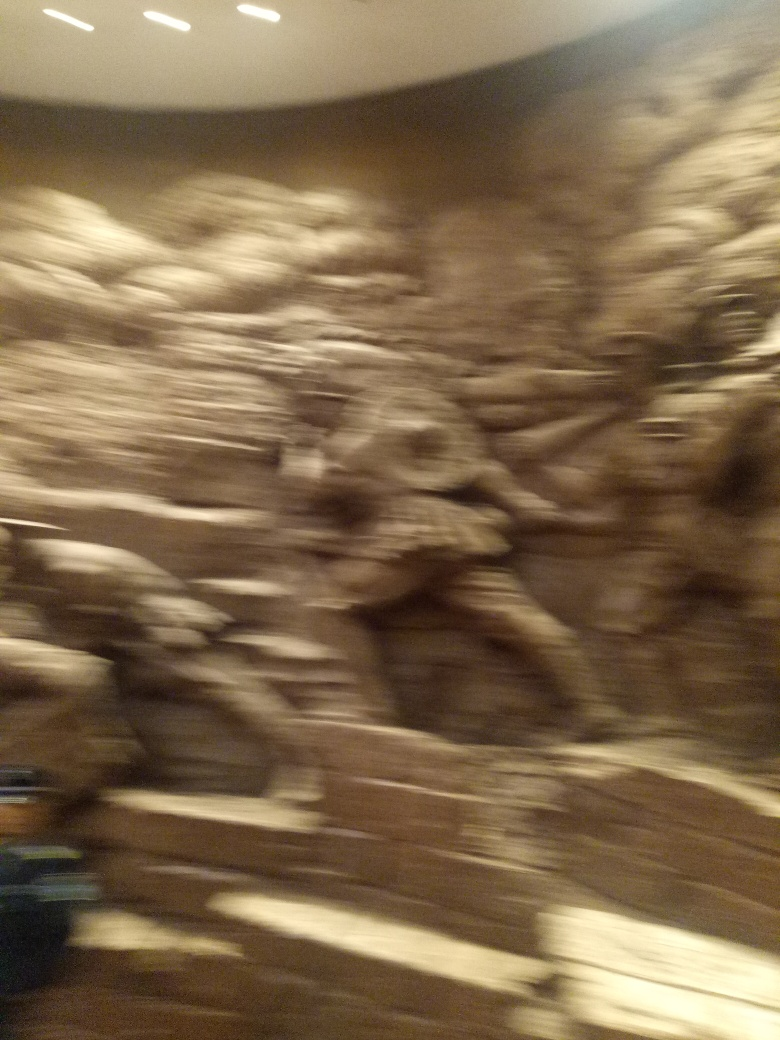This image appears blurred. Could you please describe what might have caused this effect? The blurriness in the image is likely due to camera shake or a slow shutter speed while capturing the photo. This happens when the camera moves during the exposure, especially if the shutter is open for a longer time to compensate for low light conditions. To prevent such blur, a faster shutter speed, a steadier hand or the use of a tripod can be helpful. 